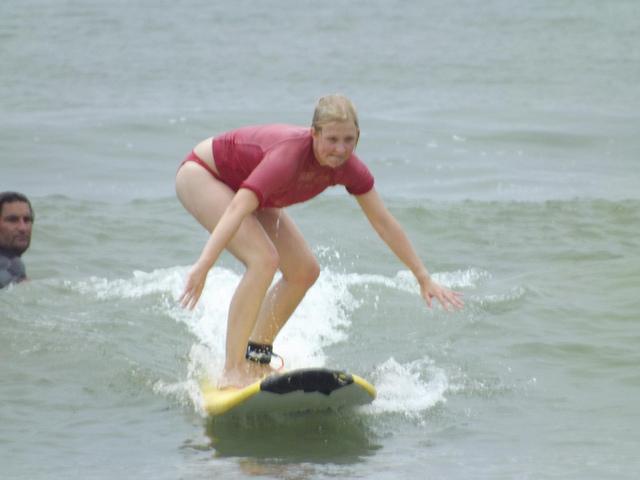What color is the water?
Answer briefly. Blue. Is this person wearing a watch?
Short answer required. No. Is the women wearing a bikini?
Short answer required. Yes. What is this girl doing?
Short answer required. Surfing. 